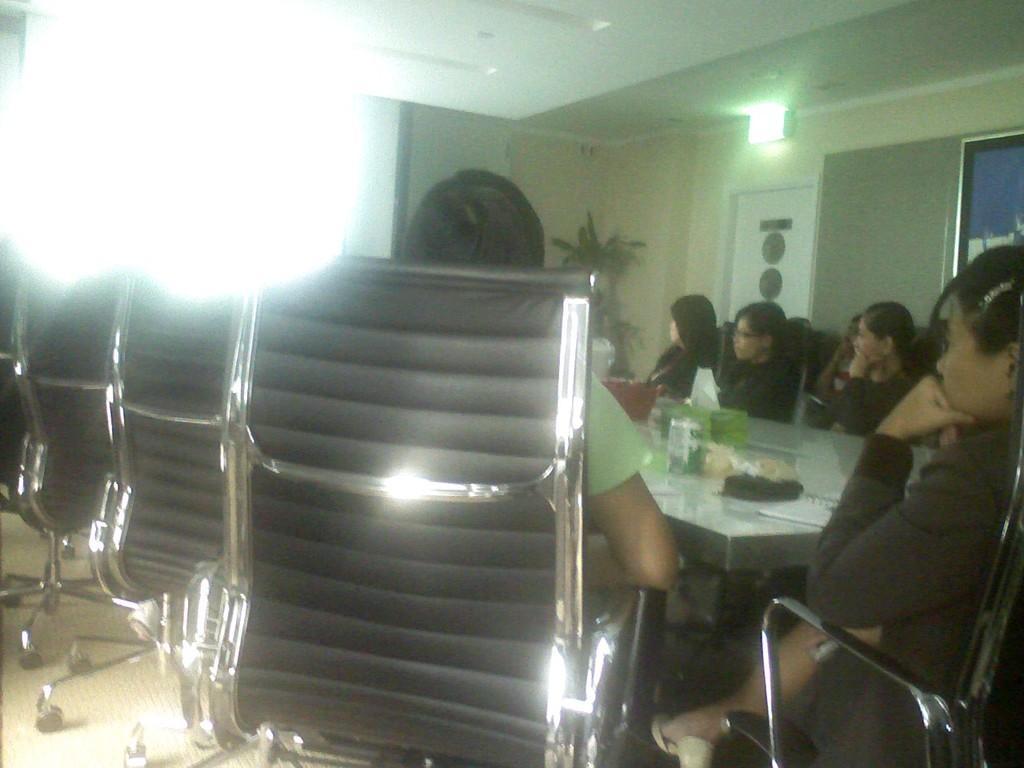How would you summarize this image in a sentence or two? In the center of the image we can see a few people are sitting on the chairs around the table. On the table, we can see some objects. In the background there is a wall, plant, door, lights and a few other objects. 